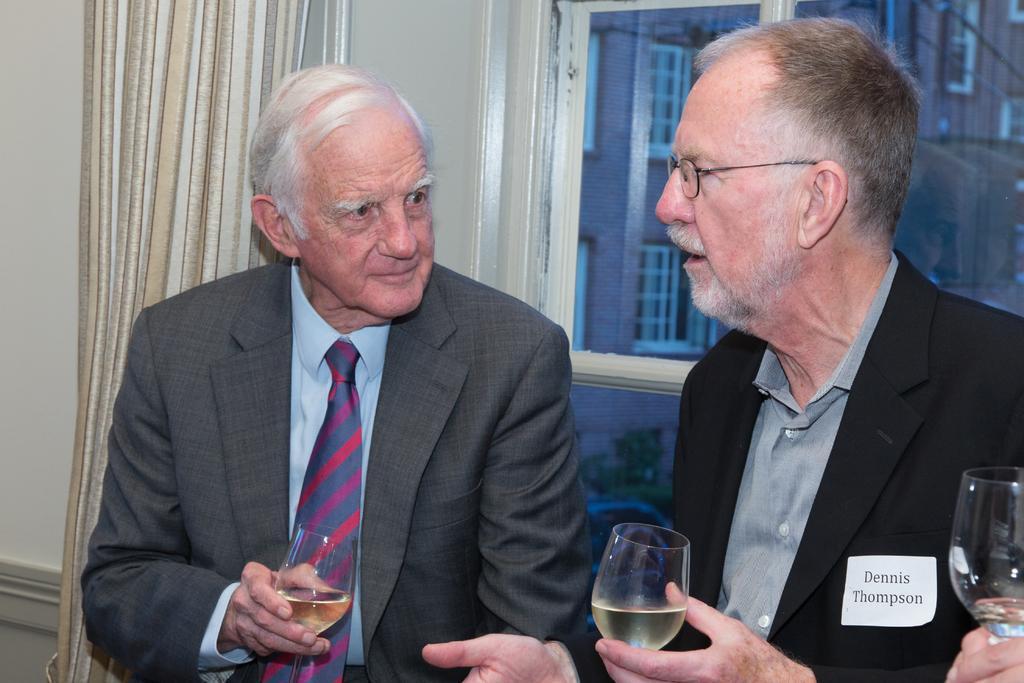Describe this image in one or two sentences. These 2 persons are holding a glasses with liquid. These 2 persons wore suits. From this window we can able to see building with window. This is curtain. 